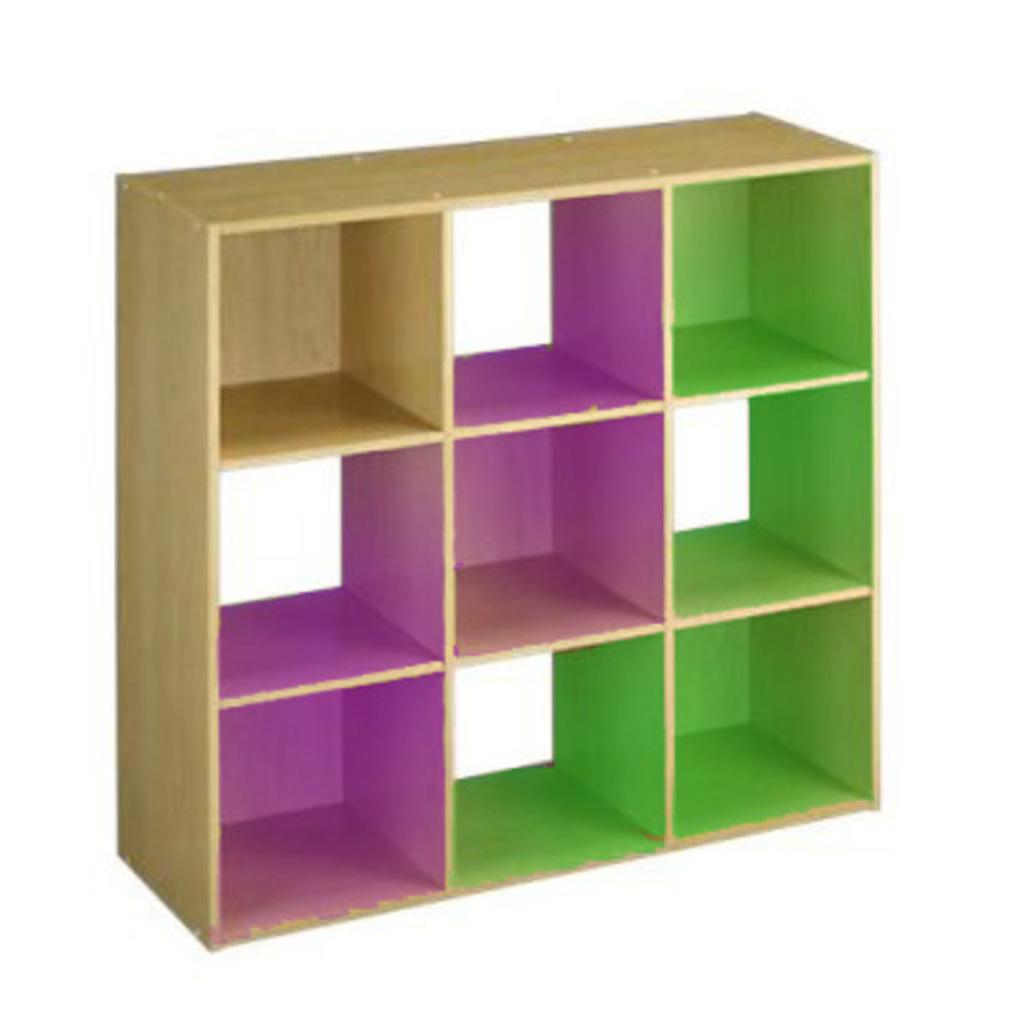What is the main object in the image? There is a wooden rack in the image. What colors can be seen on the wooden rack? The wooden rack has pink and green colors on it. Can you see a mark made by a kitty on the wooden rack in the image? There is no mention of a kitty or any mark in the image, so it cannot be determined if a kitty made a mark on the wooden rack. 